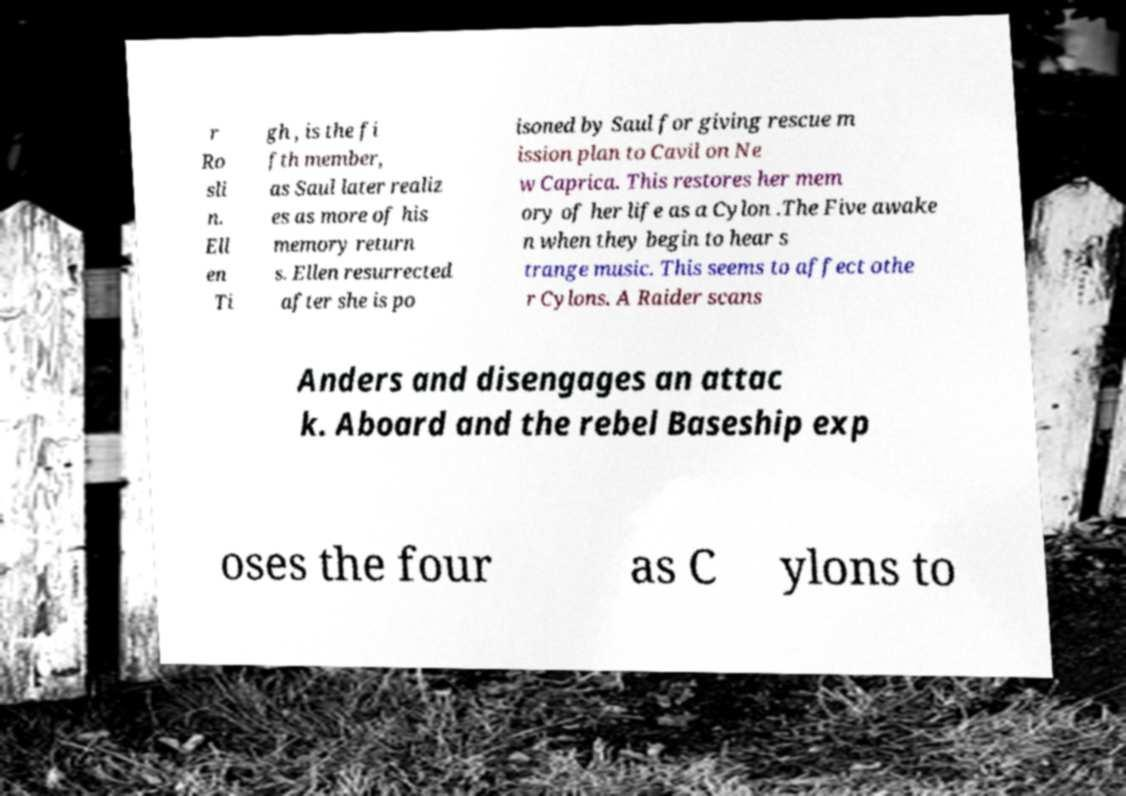Please read and relay the text visible in this image. What does it say? r Ro sli n. Ell en Ti gh , is the fi fth member, as Saul later realiz es as more of his memory return s. Ellen resurrected after she is po isoned by Saul for giving rescue m ission plan to Cavil on Ne w Caprica. This restores her mem ory of her life as a Cylon .The Five awake n when they begin to hear s trange music. This seems to affect othe r Cylons. A Raider scans Anders and disengages an attac k. Aboard and the rebel Baseship exp oses the four as C ylons to 